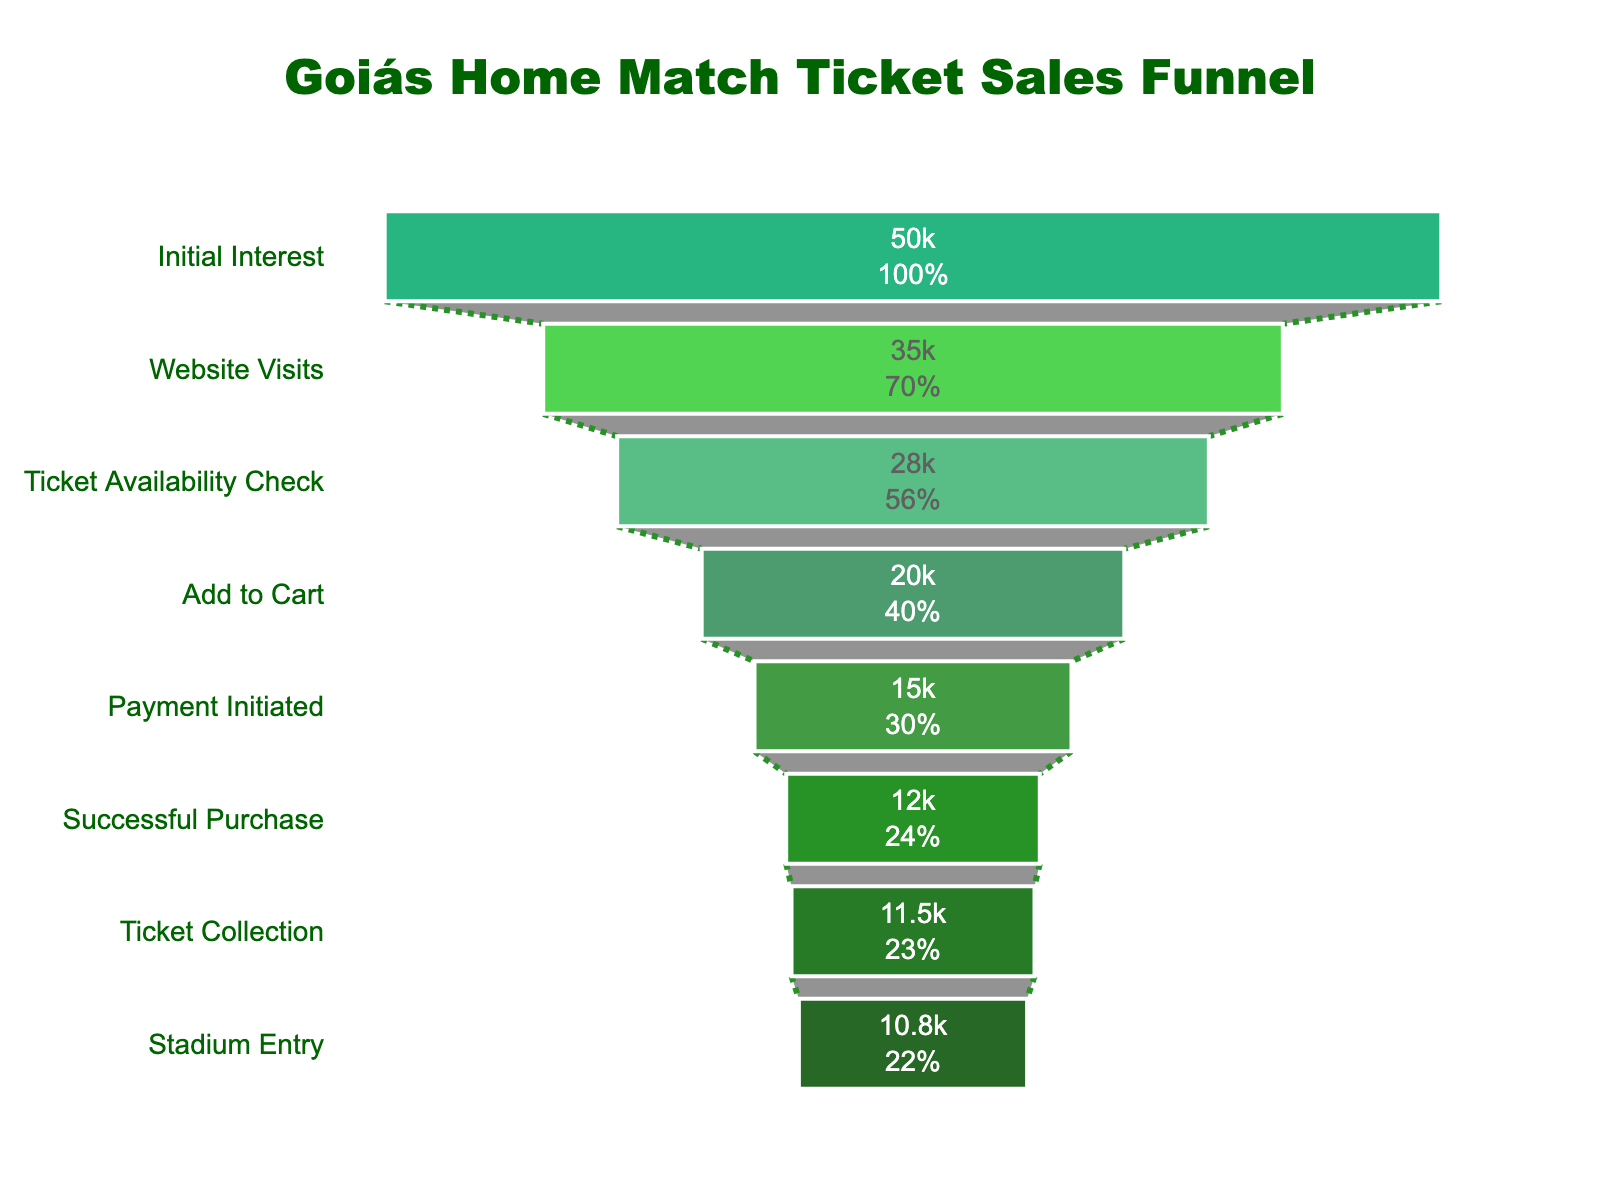What's the title of the figure? The title of the chart is typically found at the top-center of the figure. In this case, it reads "Goiás Home Match Ticket Sales Funnel".
Answer: Goiás Home Match Ticket Sales Funnel How many stages are shown in the funnel? By counting the individual stages listed on the y-axis, we can see there are eight stages displayed in the funnel chart.
Answer: Eight What percentage of initial interest led to successful ticket purchases? The count at the "Initial Interest" stage is 50,000 and the count at the "Successful Purchase" stage is 12,000. To find the percentage, calculate (12,000 / 50,000) * 100.
Answer: 24% Which stage has the largest drop-off in number of people? The largest drop-off can be identified by finding the stage with the biggest difference between consecutive stages. Here, the difference is greatest between "Website Visits" (35,000) and "Ticket Availability Check" (28,000). The drop-off is 7,000 people.
Answer: Website Visits to Ticket Availability Check How many people successfully entered the stadium? The final stage in the funnel "Stadium Entry" shows the count of people who entered the stadium, which is 10,800.
Answer: 10,800 What is the difference in number of people between the "Payment Initiated" and "Successful Purchase" stages? Subtract the count at the "Successful Purchase" stage (15,000) from the count at the "Payment Initiated" stage (12,000).
Answer: 3,000 Which stage immediately precedes "Payment Initiated"? The order of the funnel stages shows that "Add to Cart" is directly before "Payment Initiated".
Answer: Add to Cart What is the primary color used in the chart, and why do you think it was chosen? The shades of green are the primary colors used in the chart. This choice likely reflects the team colors of Goiás, reinforcing the thematic branding.
Answer: Green What proportion of people who added tickets to the cart eventually entered the stadium? The count in the "Add to Cart" stage is 20,000 and the count at "Stadium Entry" is 10,800. The proportion is calculated as (10,800 / 20,000) * 100.
Answer: 54% Which stage has the smallest drop-off in number of people? The smallest drop-off occurs between "Ticket Collection" (11,500) and "Stadium Entry" (10,800), indicating a difference of 700 people.
Answer: Ticket Collection to Stadium Entry 